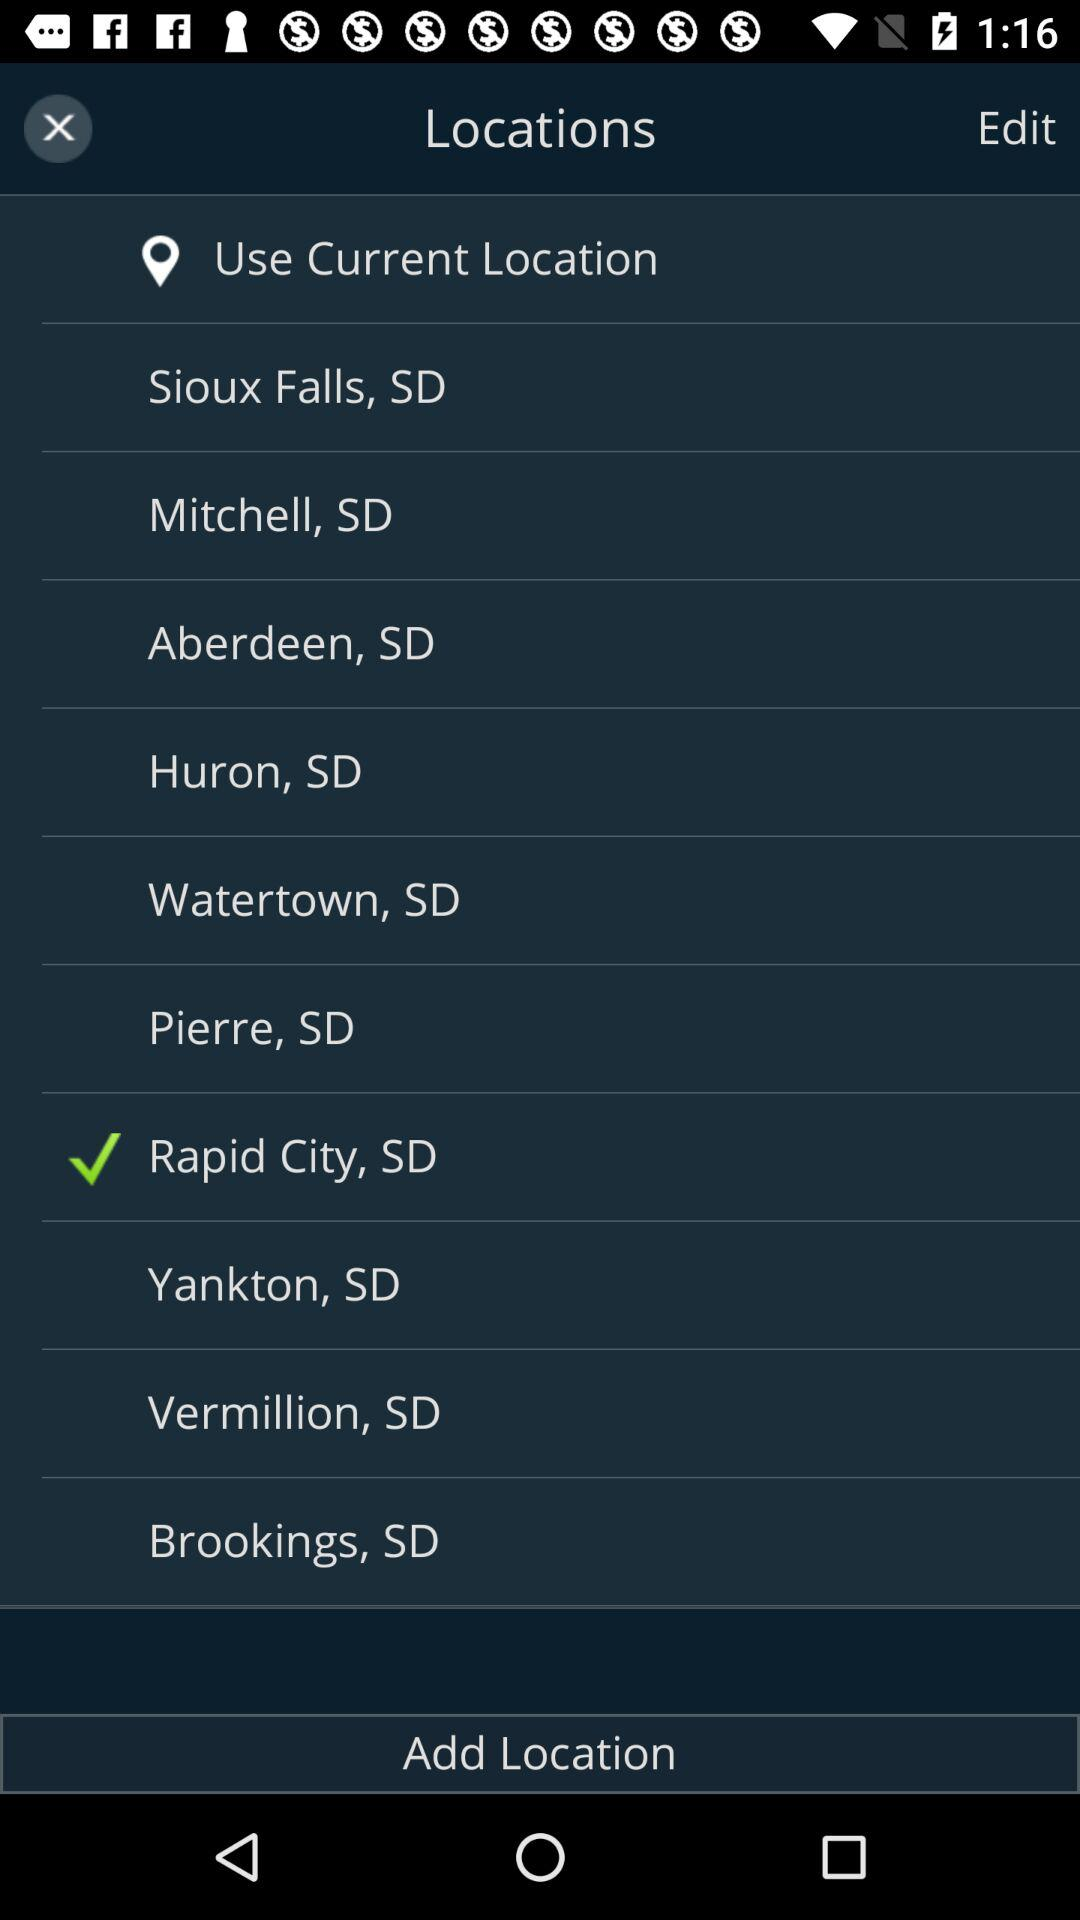What are the available locations? The available locations are Sioux Falls, SD; Mitchell, SD; Aberdeen, SD; Huron, SD; Watertown, SD; Pierre, SD; Rapid City, SD; Yankton, SD; Vermillion, SD and Brookings, SD. 